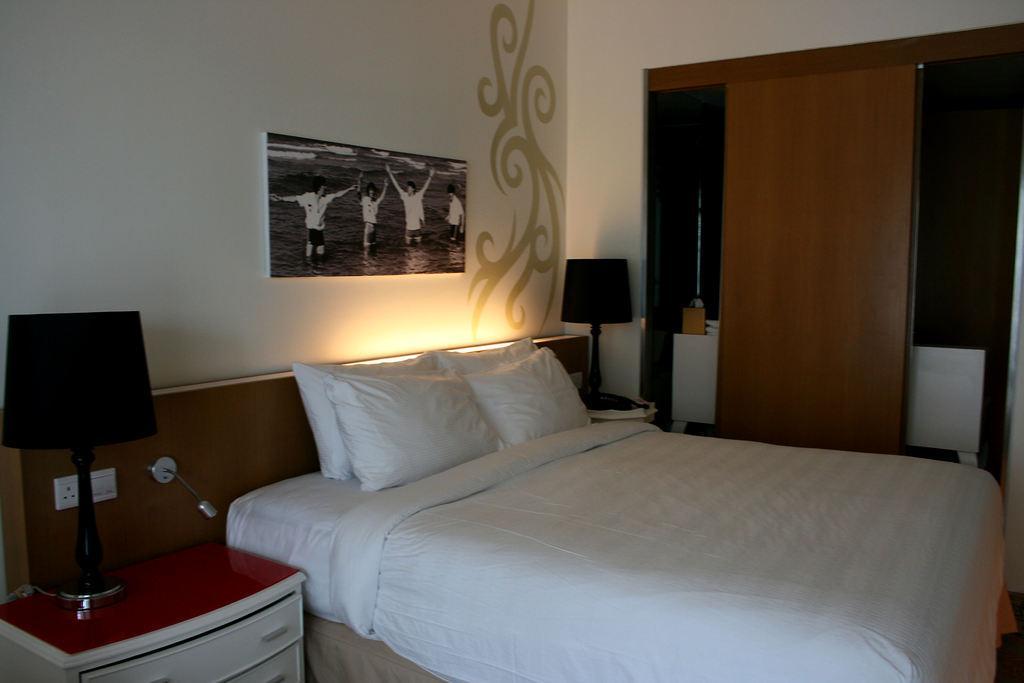Describe this image in one or two sentences. In this picture I can see the pillows on a bed. There are lamps on either side of this image, in the background there is a photo frame on the wall. On the left side I can see the switches and an electric socket. 